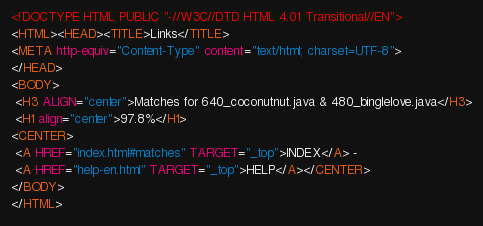Convert code to text. <code><loc_0><loc_0><loc_500><loc_500><_HTML_><!DOCTYPE HTML PUBLIC "-//W3C//DTD HTML 4.01 Transitional//EN">
<HTML><HEAD><TITLE>Links</TITLE>
<META http-equiv="Content-Type" content="text/html; charset=UTF-8">
</HEAD>
<BODY>
 <H3 ALIGN="center">Matches for 640_coconutnut.java & 480_binglelove.java</H3>
 <H1 align="center">97.8%</H1>
<CENTER>
 <A HREF="index.html#matches" TARGET="_top">INDEX</A> - 
 <A HREF="help-en.html" TARGET="_top">HELP</A></CENTER>
</BODY>
</HTML>
</code> 